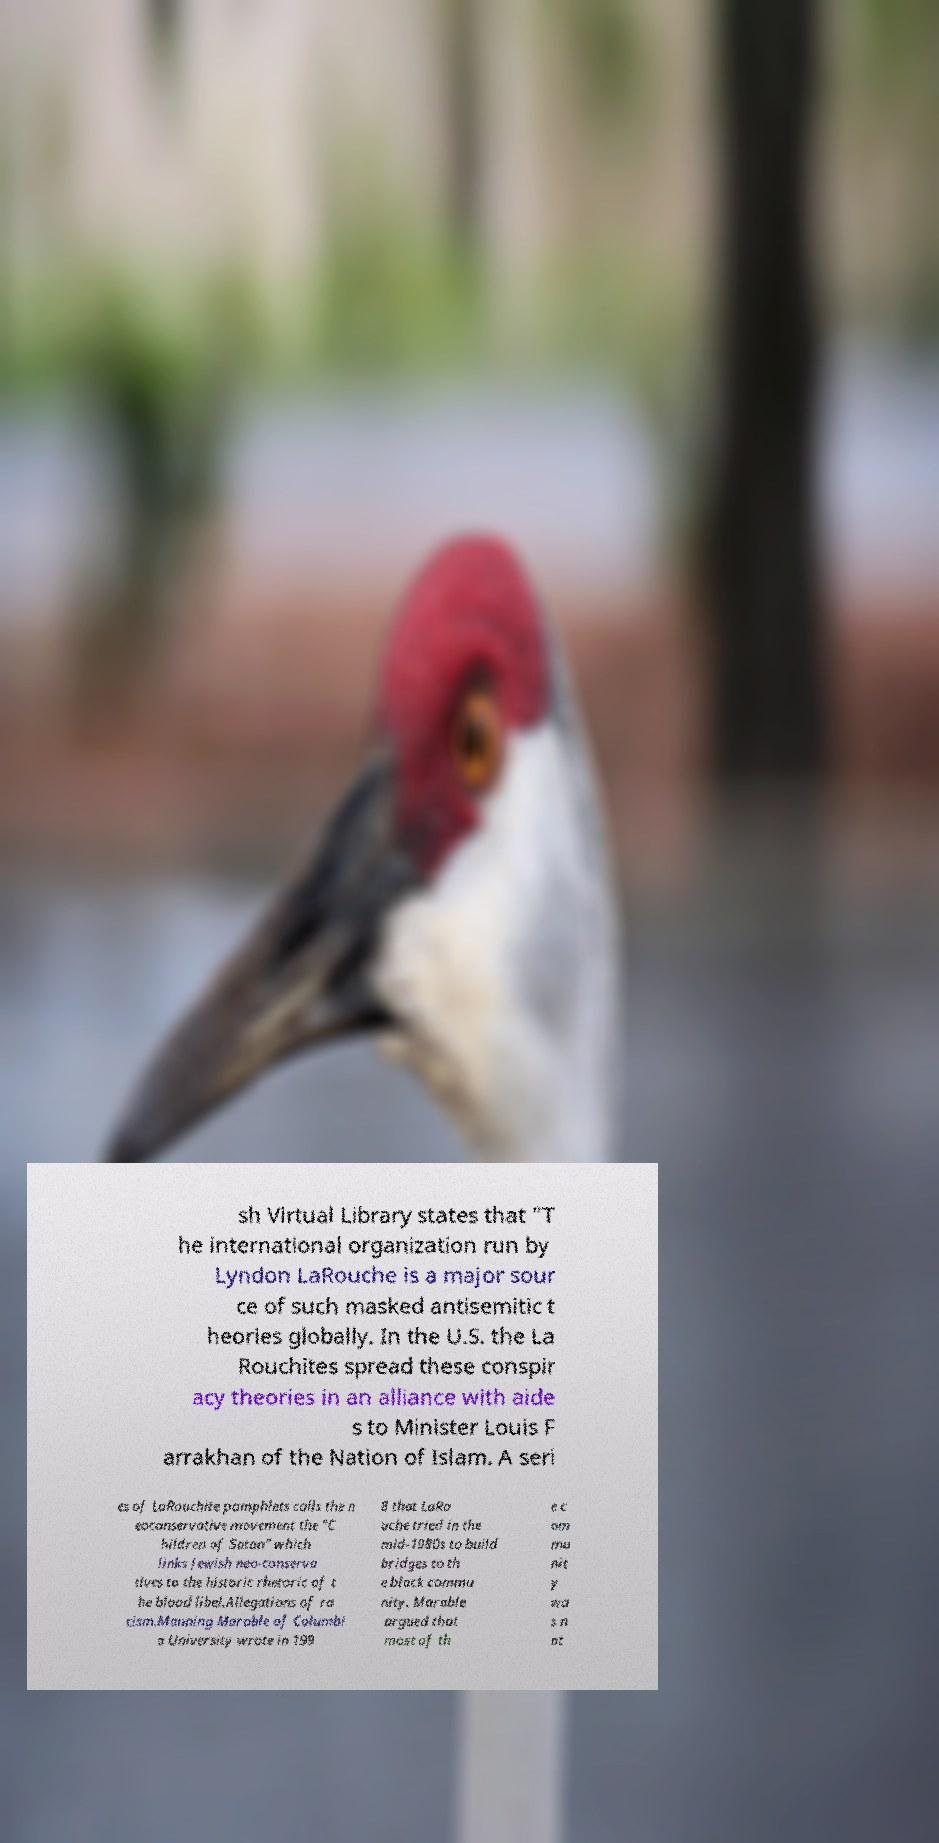I need the written content from this picture converted into text. Can you do that? sh Virtual Library states that "T he international organization run by Lyndon LaRouche is a major sour ce of such masked antisemitic t heories globally. In the U.S. the La Rouchites spread these conspir acy theories in an alliance with aide s to Minister Louis F arrakhan of the Nation of Islam. A seri es of LaRouchite pamphlets calls the n eoconservative movement the "C hildren of Satan" which links Jewish neo-conserva tives to the historic rhetoric of t he blood libel.Allegations of ra cism.Manning Marable of Columbi a University wrote in 199 8 that LaRo uche tried in the mid-1980s to build bridges to th e black commu nity. Marable argued that most of th e c om mu nit y wa s n ot 